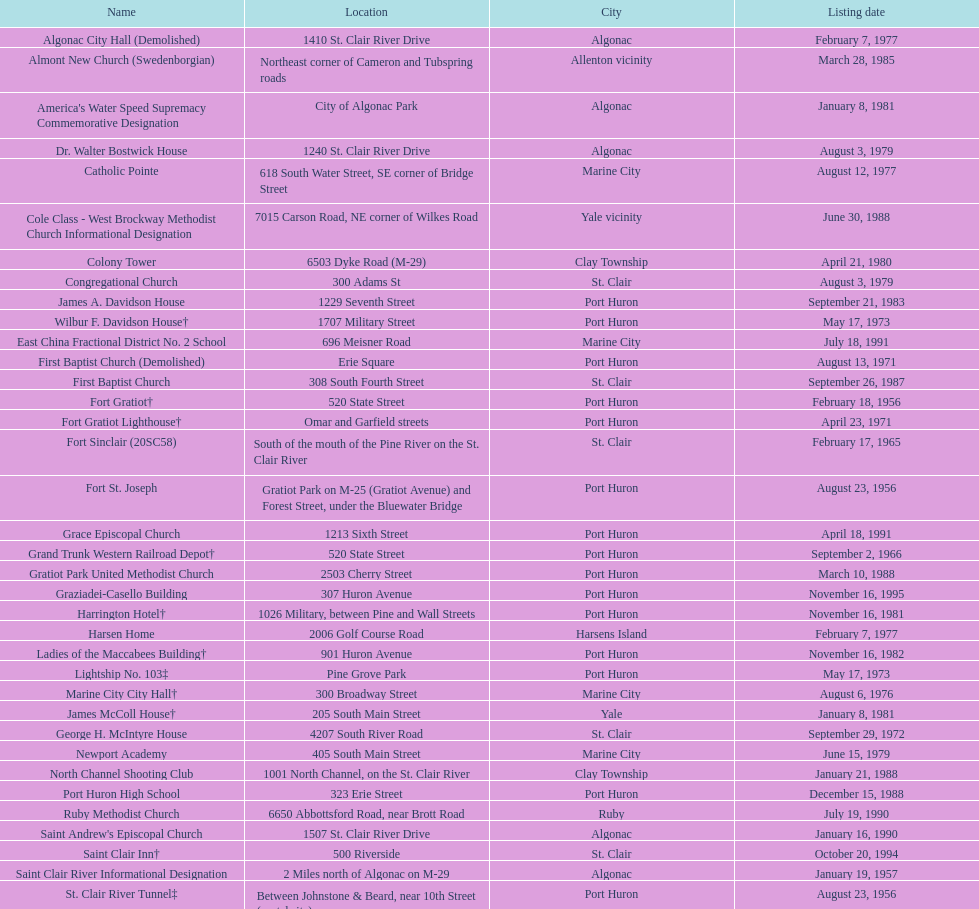How many names have no photos alongside them? 41. 